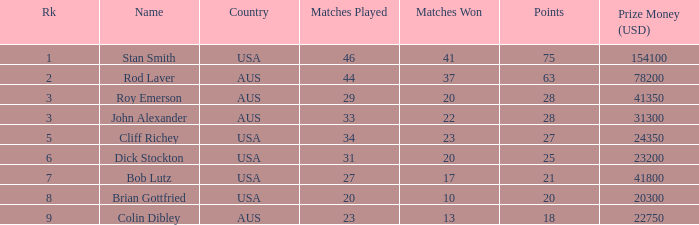How many matches did the player that played 23 matches win 13.0. 